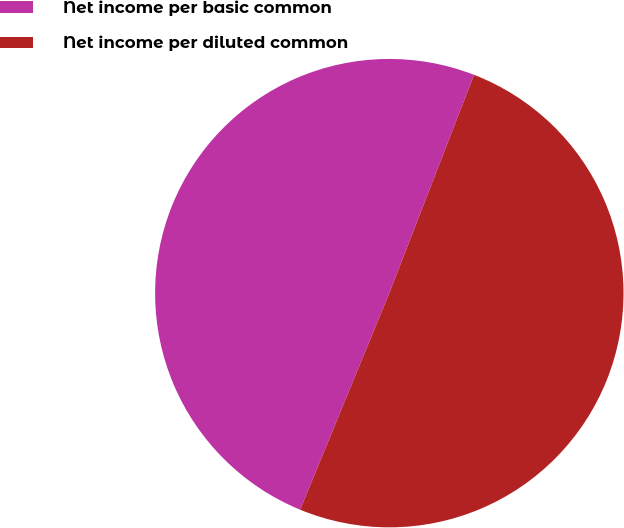Convert chart to OTSL. <chart><loc_0><loc_0><loc_500><loc_500><pie_chart><fcel>Net income per basic common<fcel>Net income per diluted common<nl><fcel>49.68%<fcel>50.32%<nl></chart> 